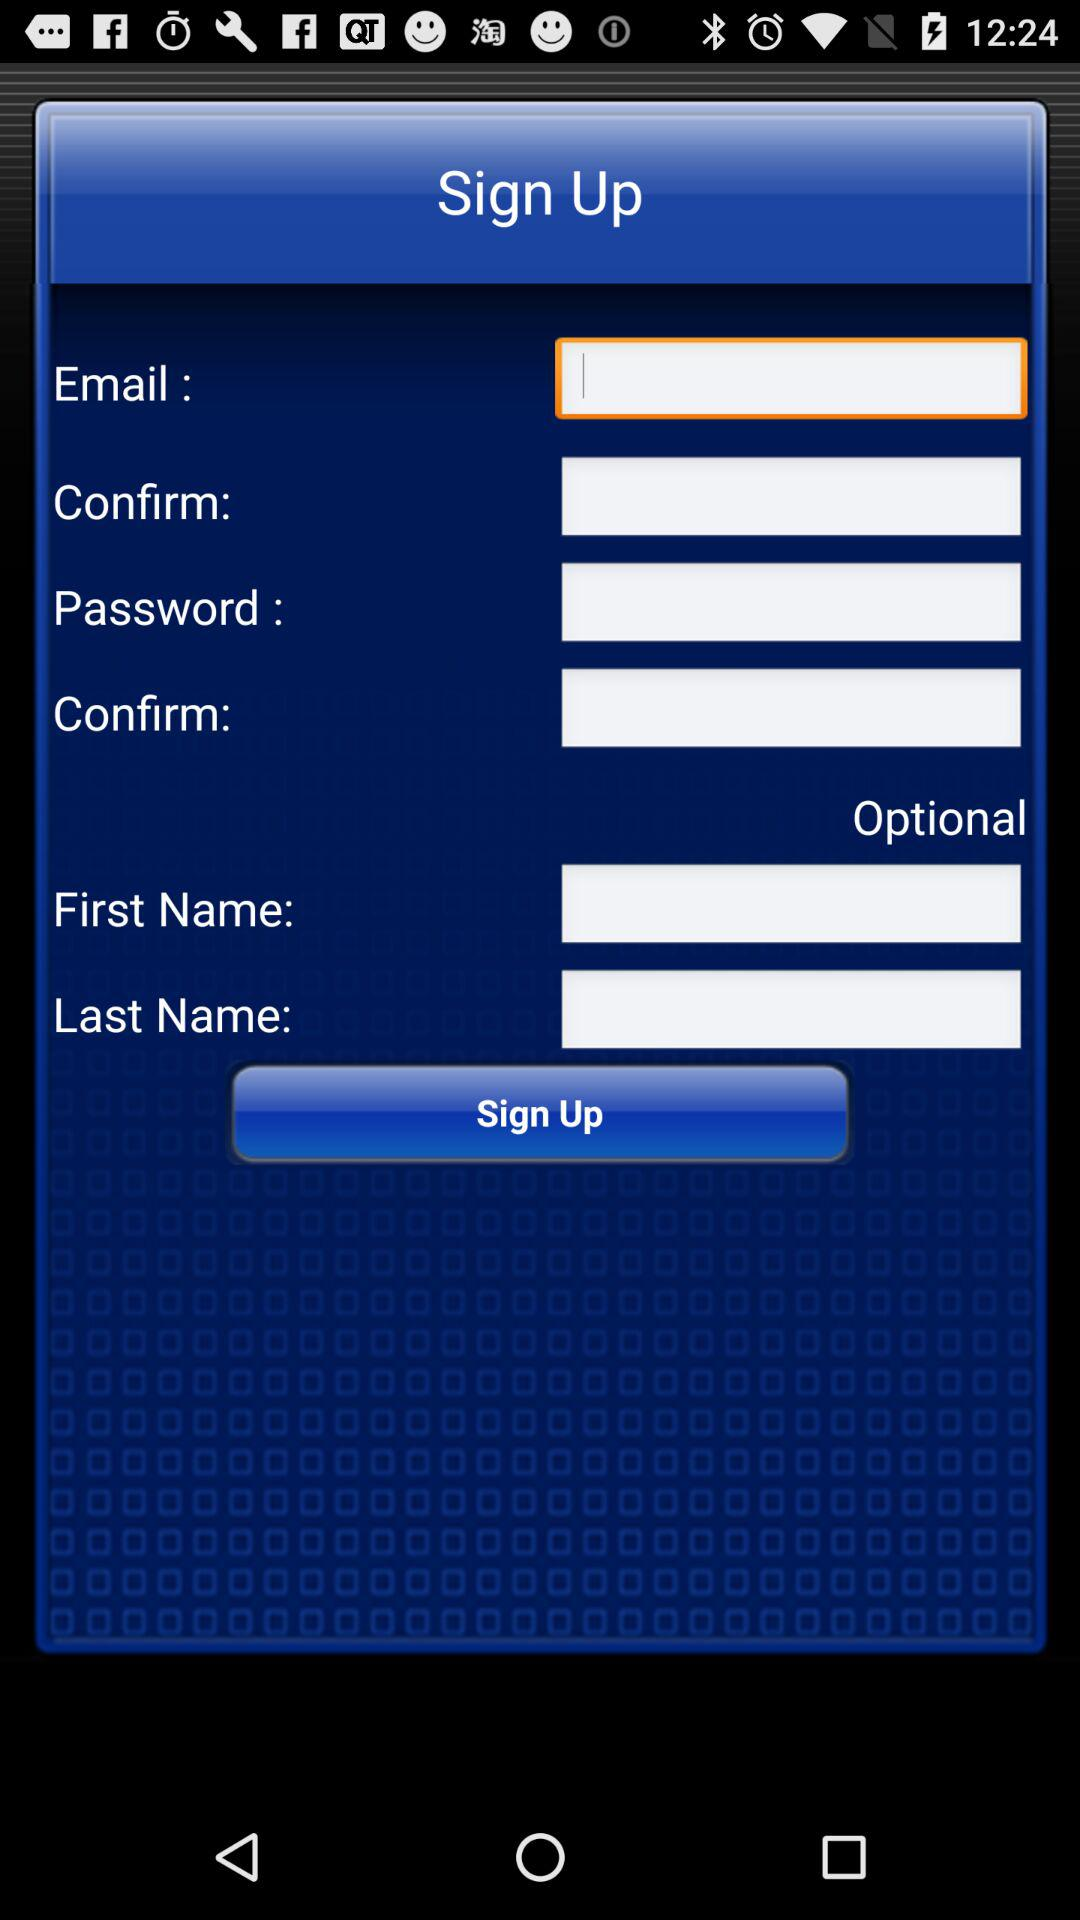How many text inputs are there for optional fields?
Answer the question using a single word or phrase. 2 